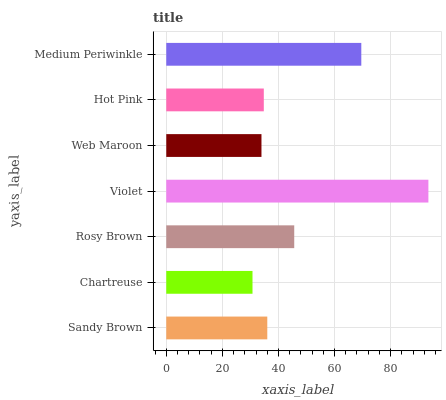Is Chartreuse the minimum?
Answer yes or no. Yes. Is Violet the maximum?
Answer yes or no. Yes. Is Rosy Brown the minimum?
Answer yes or no. No. Is Rosy Brown the maximum?
Answer yes or no. No. Is Rosy Brown greater than Chartreuse?
Answer yes or no. Yes. Is Chartreuse less than Rosy Brown?
Answer yes or no. Yes. Is Chartreuse greater than Rosy Brown?
Answer yes or no. No. Is Rosy Brown less than Chartreuse?
Answer yes or no. No. Is Sandy Brown the high median?
Answer yes or no. Yes. Is Sandy Brown the low median?
Answer yes or no. Yes. Is Chartreuse the high median?
Answer yes or no. No. Is Web Maroon the low median?
Answer yes or no. No. 